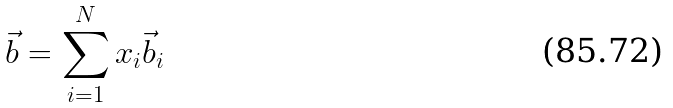Convert formula to latex. <formula><loc_0><loc_0><loc_500><loc_500>\vec { b } = \sum _ { i = 1 } ^ { N } x _ { i } \vec { b } _ { i }</formula> 